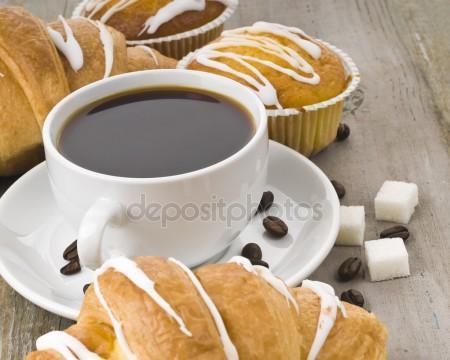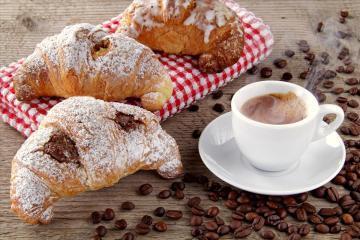The first image is the image on the left, the second image is the image on the right. Assess this claim about the two images: "One of the images has a human being visible.". Correct or not? Answer yes or no. No. 